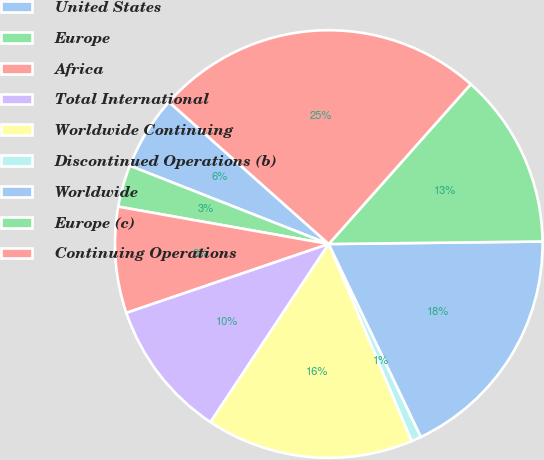<chart> <loc_0><loc_0><loc_500><loc_500><pie_chart><fcel>United States<fcel>Europe<fcel>Africa<fcel>Total International<fcel>Worldwide Continuing<fcel>Discontinued Operations (b)<fcel>Worldwide<fcel>Europe (c)<fcel>Continuing Operations<nl><fcel>5.6%<fcel>3.17%<fcel>8.02%<fcel>10.45%<fcel>15.67%<fcel>0.75%<fcel>18.1%<fcel>13.25%<fcel>25.0%<nl></chart> 